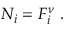Convert formula to latex. <formula><loc_0><loc_0><loc_500><loc_500>\begin{array} { r } { N _ { i } = F _ { i } ^ { \nu } \ . } \end{array}</formula> 